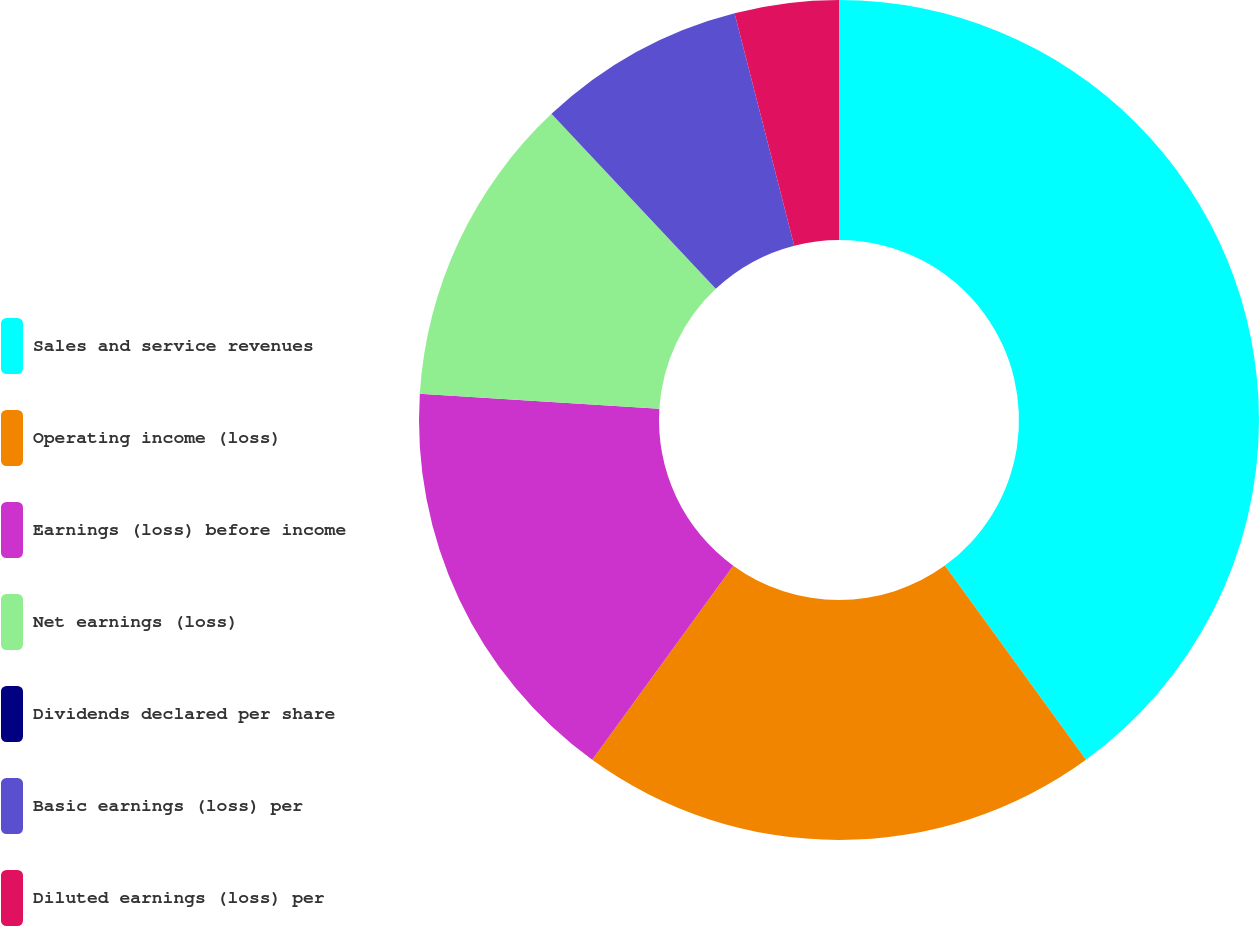Convert chart to OTSL. <chart><loc_0><loc_0><loc_500><loc_500><pie_chart><fcel>Sales and service revenues<fcel>Operating income (loss)<fcel>Earnings (loss) before income<fcel>Net earnings (loss)<fcel>Dividends declared per share<fcel>Basic earnings (loss) per<fcel>Diluted earnings (loss) per<nl><fcel>39.99%<fcel>20.0%<fcel>16.0%<fcel>12.0%<fcel>0.0%<fcel>8.0%<fcel>4.0%<nl></chart> 